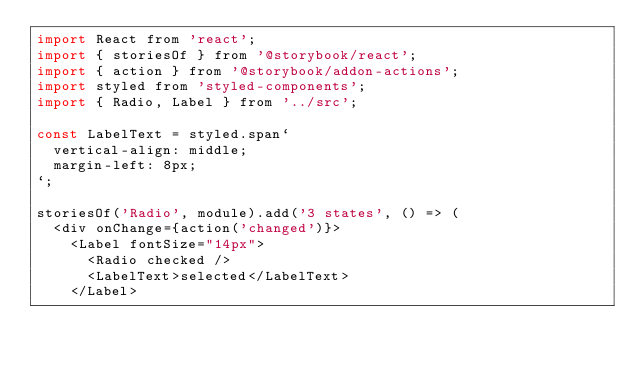Convert code to text. <code><loc_0><loc_0><loc_500><loc_500><_JavaScript_>import React from 'react';
import { storiesOf } from '@storybook/react';
import { action } from '@storybook/addon-actions';
import styled from 'styled-components';
import { Radio, Label } from '../src';

const LabelText = styled.span`
  vertical-align: middle;
  margin-left: 8px;
`;

storiesOf('Radio', module).add('3 states', () => (
  <div onChange={action('changed')}>
    <Label fontSize="14px">
      <Radio checked />
      <LabelText>selected</LabelText>
    </Label></code> 